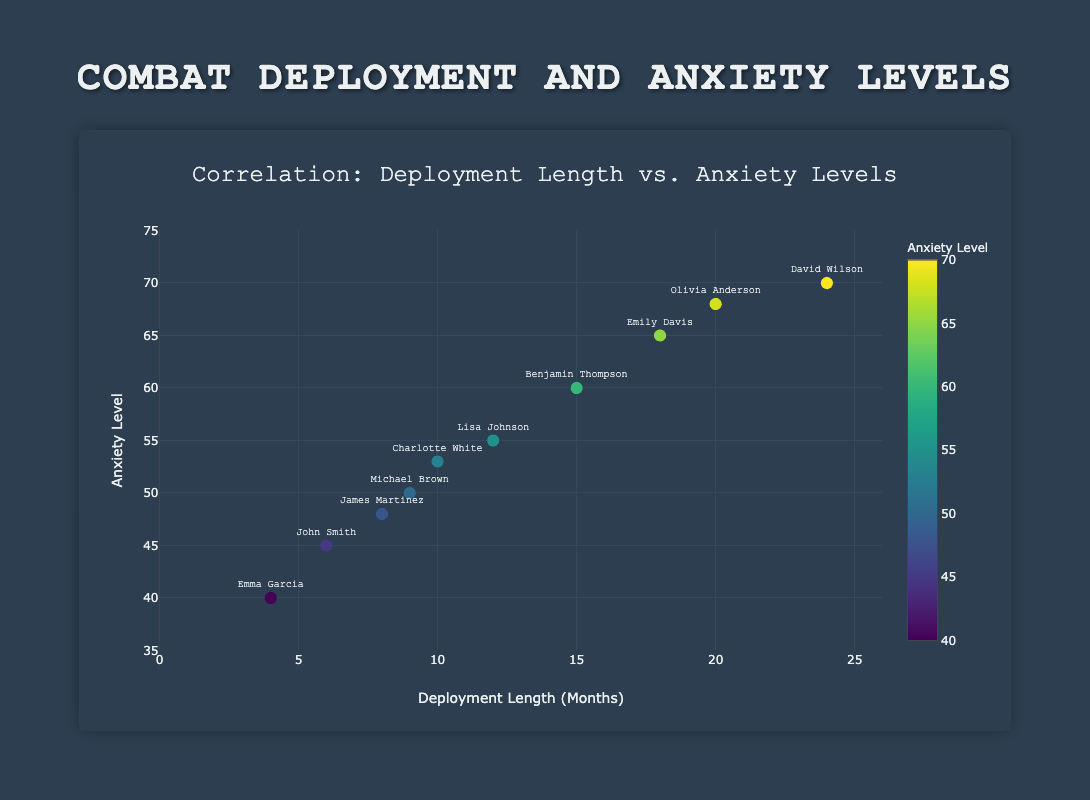What is the title of the scatter plot? The title is prominently displayed at the top of the chart. It reads "Correlation: Deployment Length vs. Anxiety Levels"
Answer: Correlation: Deployment Length vs. Anxiety Levels How many veterans are represented in the scatter plot? Each dot represents one veteran. Count each dot or use the legend if available. There are 10 veterans listed in the data provided.
Answer: 10 Which veteran has the highest anxiety level? Look for the dot on the scatter plot with the highest position on the y-axis (Anxiety Level), and note the text label. David Wilson, with an anxiety level of 70, has the highest value.
Answer: David Wilson What are the anxiety levels for veterans with deployment lengths of 6 and 24 months? Identify the dots along the x-axis at 6 and 24 months, and read the anxiety levels. John Smith has an anxiety level of 45 for 6 months, and David Wilson has an anxiety level of 70 for 24 months.
Answer: 45 for 6 months, 70 for 24 months Is there a positive correlation between deployment length and anxiety levels? Observe the overall trend of the scatter plot. If the dots generally move upwards as they move to the right, there is a positive correlation. The plot shows this upward trend, indicating a positive correlation between deployment length and anxiety levels.
Answer: Yes What is the average anxiety level of veterans with deployment lengths greater than 10 months? Identify the data points with deployment lengths greater than 10 months, sum their anxiety levels, and divide by the number of data points. The relevant veterans are Emily Davis (65), David Wilson (70), Olivia Anderson (68), and Benjamin Thompson (60), so the average is (65 + 70 + 68 + 60) / 4 = 65.75
Answer: 65.75 Which veteran has the lowest anxiety level, and what is their deployment length? Look for the dot on the scatter plot that is lowest on the y-axis and note the text label and corresponding x-axis value. Emma Garcia has the lowest anxiety level of 40, with a deployment length of 4 months.
Answer: Emma Garcia, 4 months Among veterans with a deployment length of 10 months, who has the highest anxiety level, and what is that level? There is only one veteran with a deployment length of 10 months. Cross-reference the x-axis position for 10 months and locate the corresponding y-axis value. Charlotte White has an anxiety level of 53.
Answer: Charlotte White, 53 Are there more veterans with anxiety levels above or below 50? Count the number of dots positioned above and below the 50 y-axis mark. There are 6 veterans with anxiety levels above 50 and 4 with anxiety levels below 50.
Answer: Above 50 What is the difference in anxiety levels between veterans with the longest and shortest deployment lengths? Identify the veterans with the longest and shortest deployment lengths and their corresponding anxiety levels, then subtract the smallest from the largest. David Wilson (24 months, anxiety level 70) and Emma Garcia (4 months, anxiety level 40). The difference is 70 - 40 = 30.
Answer: 30 